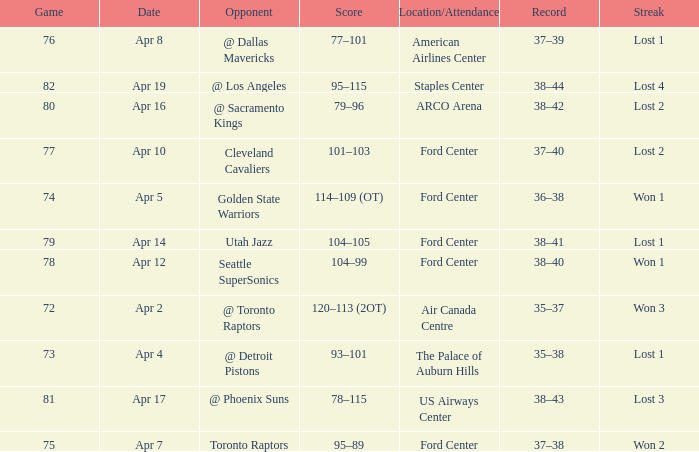Who was the opponent for game 75? Toronto Raptors. 